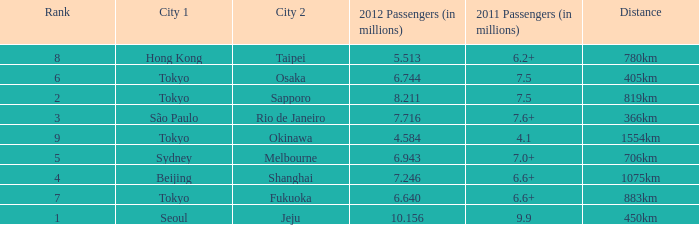Which city is listed first when Okinawa is listed as the second city? Tokyo. 